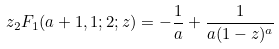Convert formula to latex. <formula><loc_0><loc_0><loc_500><loc_500>z _ { 2 } F _ { 1 } ( a + 1 , 1 ; 2 ; z ) = - \frac { 1 } { a } + \frac { 1 } { a ( 1 - z ) ^ { a } }</formula> 